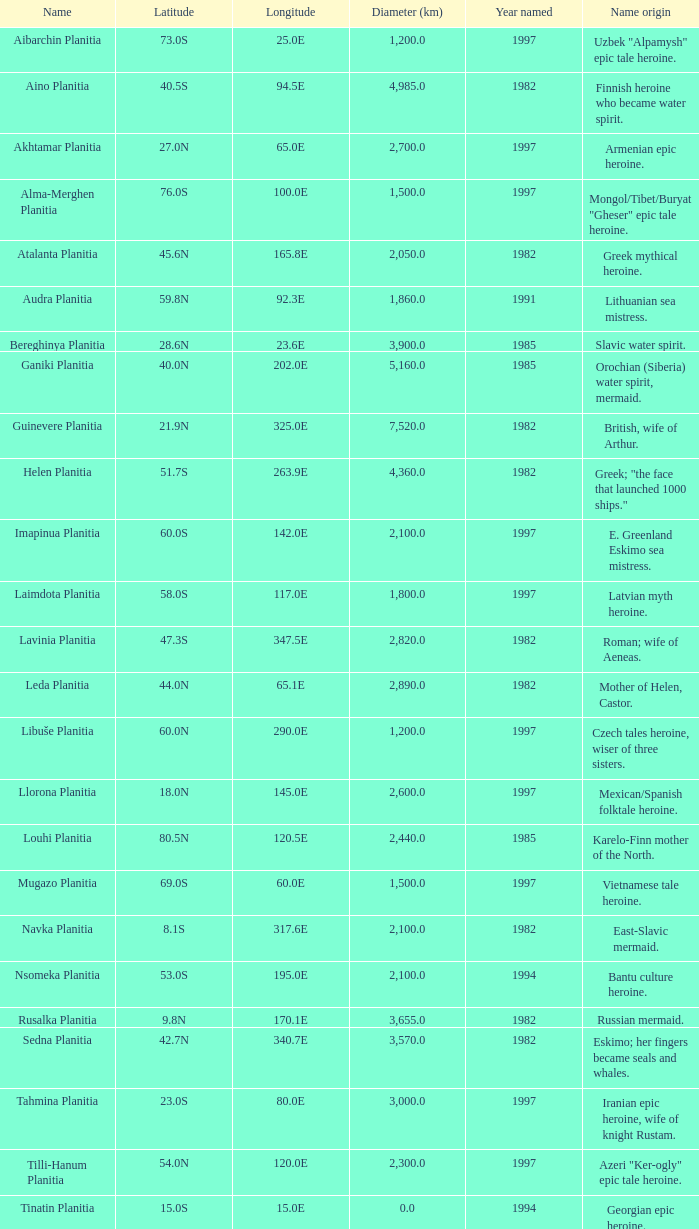What is the diameter in kilometers of longitude 170.1e? 3655.0. 